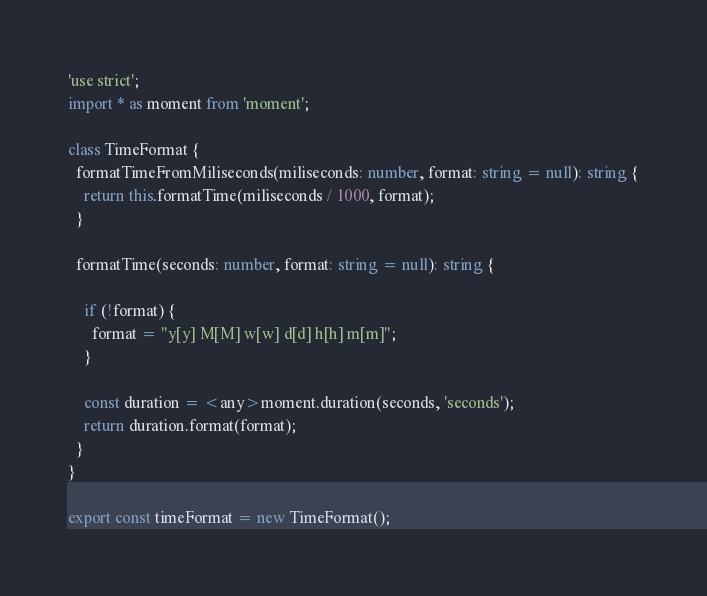<code> <loc_0><loc_0><loc_500><loc_500><_TypeScript_>'use strict';
import * as moment from 'moment';

class TimeFormat {
  formatTimeFromMiliseconds(miliseconds: number, format: string = null): string {
    return this.formatTime(miliseconds / 1000, format);
  }

  formatTime(seconds: number, format: string = null): string {

    if (!format) {
      format = "y[y] M[M] w[w] d[d] h[h] m[m]";
    }

    const duration = <any>moment.duration(seconds, 'seconds');
    return duration.format(format);
  }
}

export const timeFormat = new TimeFormat();
</code> 